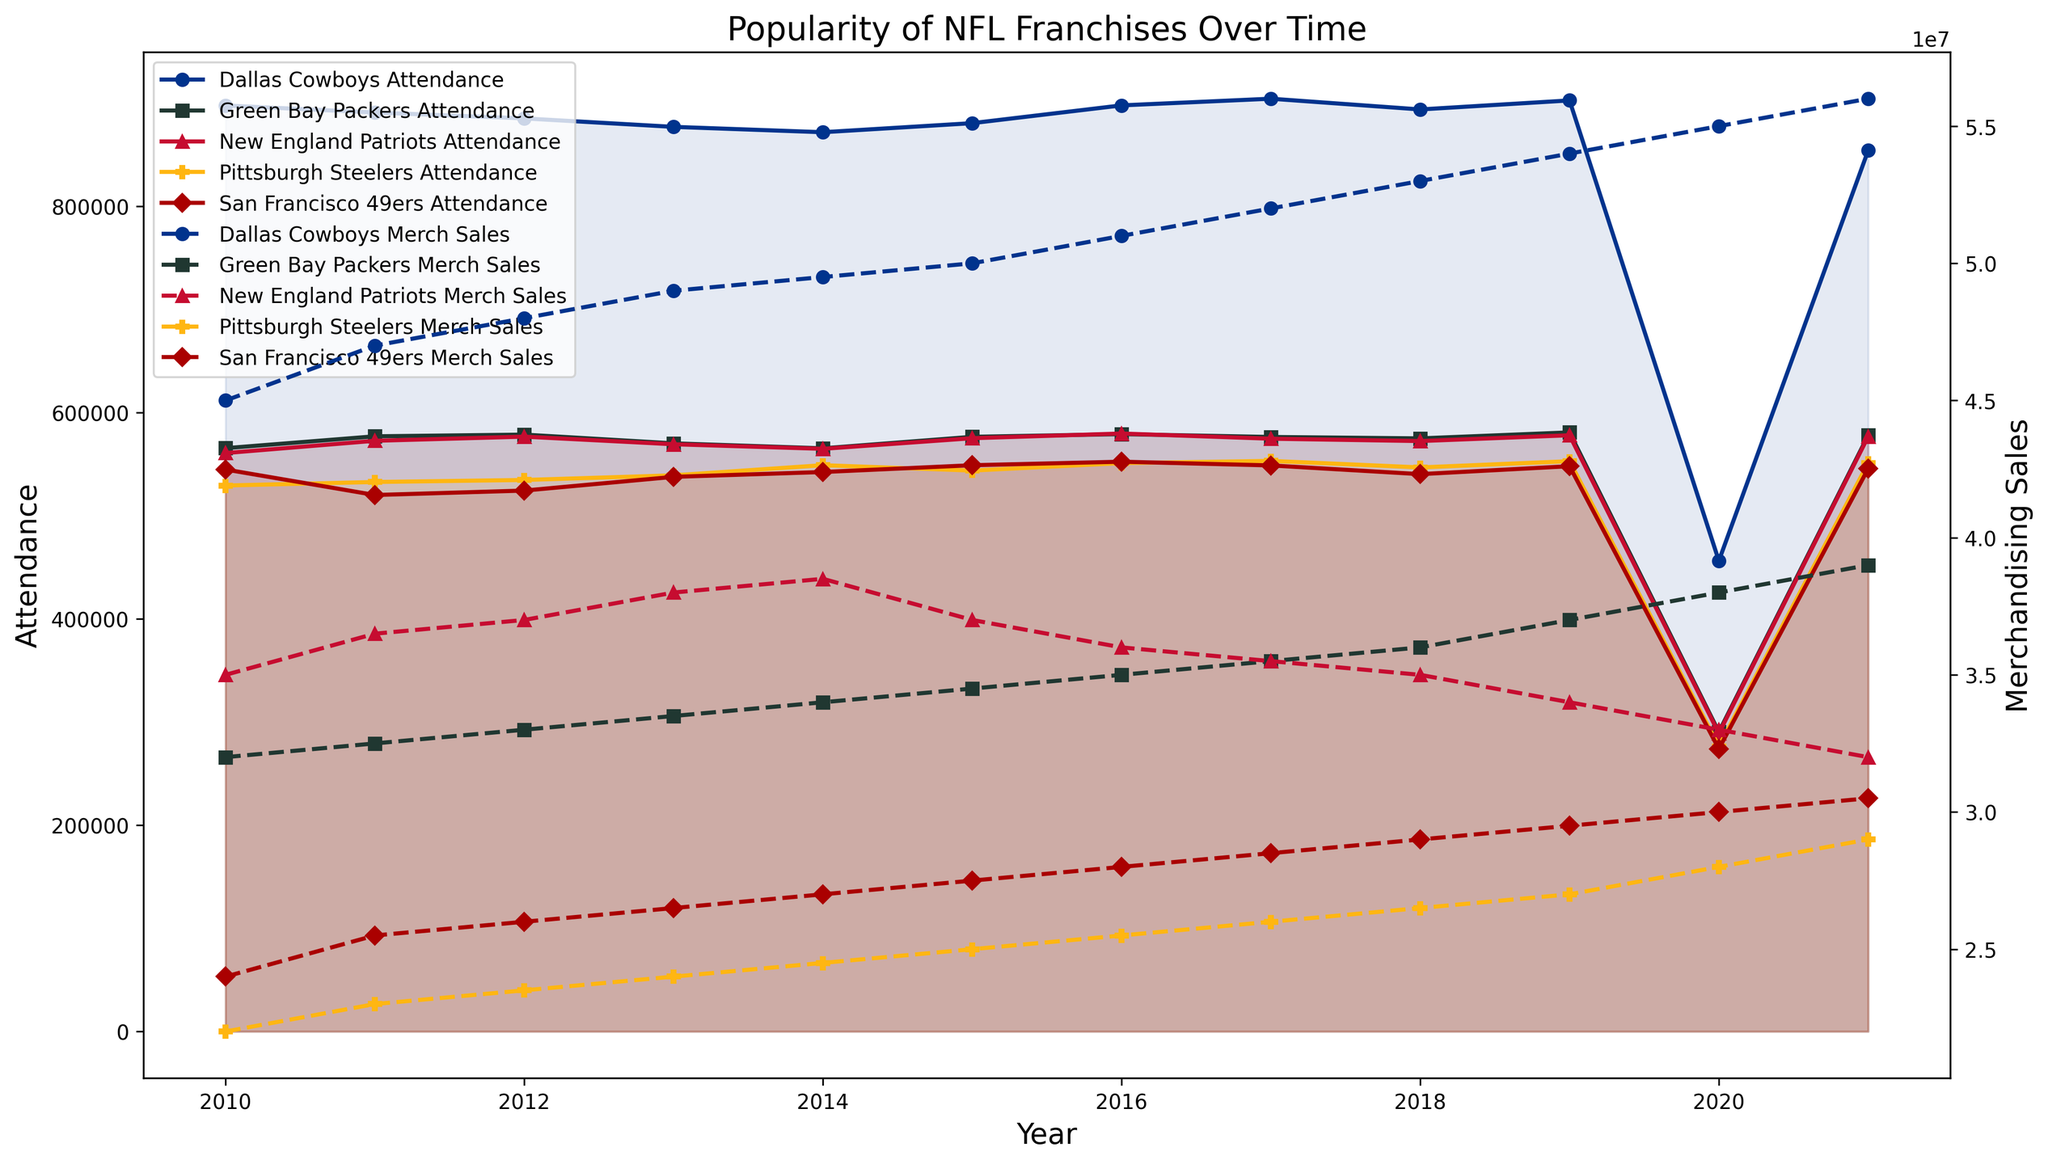How did the attendance of the Dallas Cowboys change from 2010 to 2021? To see how the attendance of the Dallas Cowboys changed over the years, we look at the plot's solid line representing the Dallas Cowboys' attendance from 2010 to 2021. It increased, peaking in 2019, and then dropped significantly in 2020 before rising again in 2021.
Answer: Increased, dropped in 2020, rose in 2021 Which franchise had the highest attendance in 2020, and what was the value? We look at the 2020 points for all franchises and see which one is the highest. The Dallas Cowboys' solid line is the highest in 2020. The value can be read from the Y-axis corresponding to the point.
Answer: Dallas Cowboys, 456,271 How did the merchandising sales of Green Bay Packers trend from 2010 to 2021? We track the dotted line for the Green Bay Packers from 2010 to 2021. This line shows a steady increase over the years without any significant drops.
Answer: Steady increase Compare the attendance of the San Francisco 49ers and Pittsburgh Steelers in 2015. Which team had higher attendance, and by how much? Look at the solid lines for San Francisco 49ers and Pittsburgh Steelers in 2015. The San Francisco 49ers was around 548,923 and Pittsburgh Steelers was around 543,729. Subtract the Steelers' attendance from the 49ers'.
Answer: San Francisco 49ers, approximately 5,194 What was the trend in merchandising sales for the New England Patriots between 2016 and 2021? Track the dotted line for the New England Patriots between 2016 and 2021. Starting at 36 million in 2016, it decreases slightly until 2021 where it reaches 32 million.
Answer: Decreasing Which franchise showed the greatest increase in merchandising sales between 2020 and 2021? Look at the dotted lines for all franchises from 2020 to 2021. Compare the differences. Green Bay Packers increased from 38 to 39 million, New England Patriots decreased, Dallas Cowboys increased from 55 to 56 million, San Francisco 49ers increased from 30 to 30.5 million, and Pittsburgh Steelers increased from 28 to 29 million.
Answer: Green Bay Packers, 1 million Is there a correlation between attendance and merchandising sales for franchises over the years? Visually inspect the chart. If solid and dotted lines for a franchise move similarly over time, a correlation is likely. For instance, Dallas Cowboys' attendance and sales both generally increased, same for Green Bay Packers.
Answer: Yes, there seems to be a positive correlation How did the pandemic year (2020) affect the attendance of all the franchises? Look at the solid lines for 2020 for all franchises. All show a significant drop compared to previous years, indicating that attendance was greatly reduced for all franchises.
Answer: Significant drop for all franchises What is the average attendance of the Dallas Cowboys from 2015 to 2019? Look at the Dallas Cowboys' solid lines for the years 2015, 2016, 2017, 2018, and 2019. Add these values and divide by 5. The values are approximately 880,507, 897,743, 904,218, 893,798, and 902,543.
Answer: Approximately 895,362 